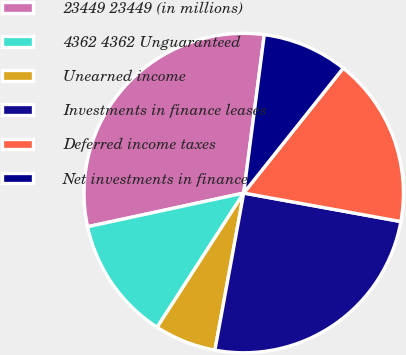Convert chart. <chart><loc_0><loc_0><loc_500><loc_500><pie_chart><fcel>23449 23449 (in millions)<fcel>4362 4362 Unguaranteed<fcel>Unearned income<fcel>Investments in finance leases<fcel>Deferred income taxes<fcel>Net investments in finance<nl><fcel>30.44%<fcel>12.5%<fcel>6.23%<fcel>25.03%<fcel>17.15%<fcel>8.65%<nl></chart> 